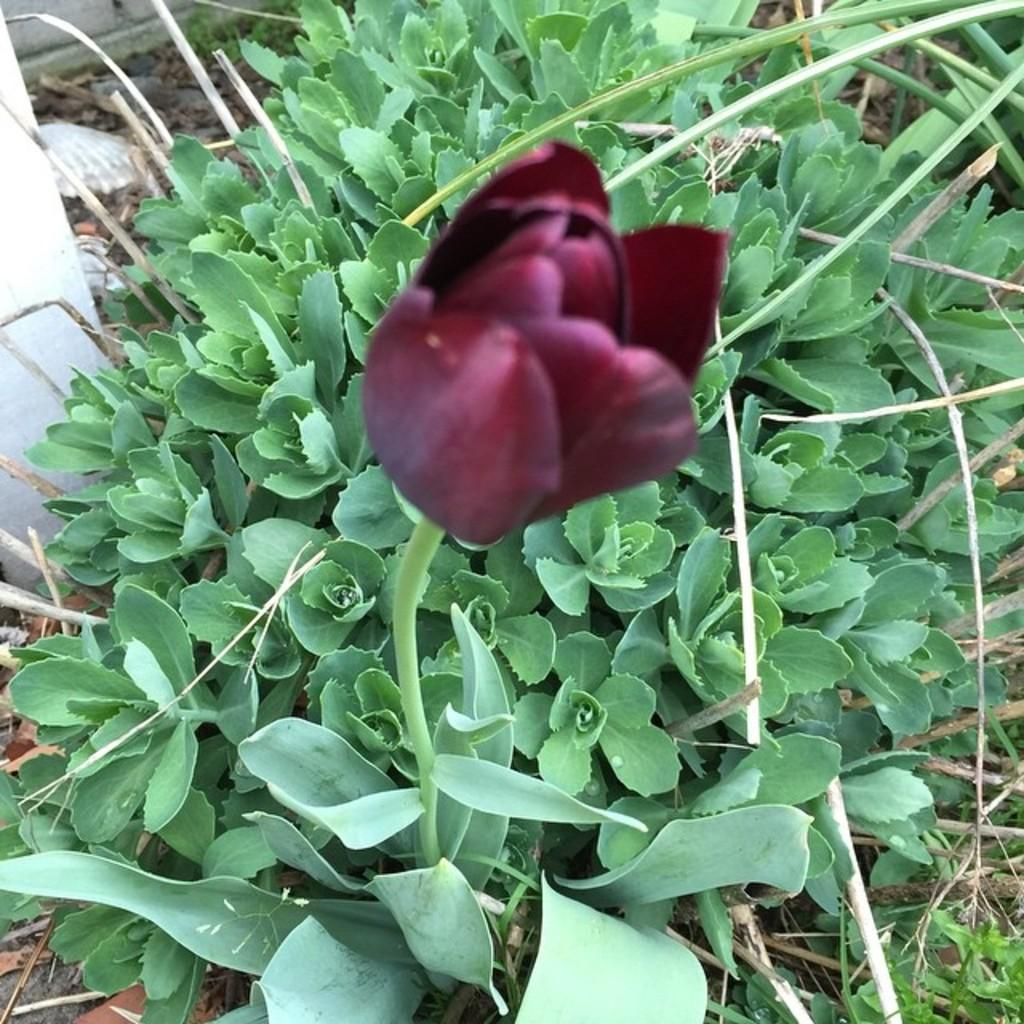What is the main subject in the center of the image? There is a flower in the center of the image. What other plants can be seen at the bottom of the image? There are plants at the bottom of the image. What type of vegetation is visible in the image? There is grass visible in the image. How many ducks are present in the image? There are no ducks present in the image. What type of cough is the mother treating in the image? There is no reference to a cough or a mother in the image. 